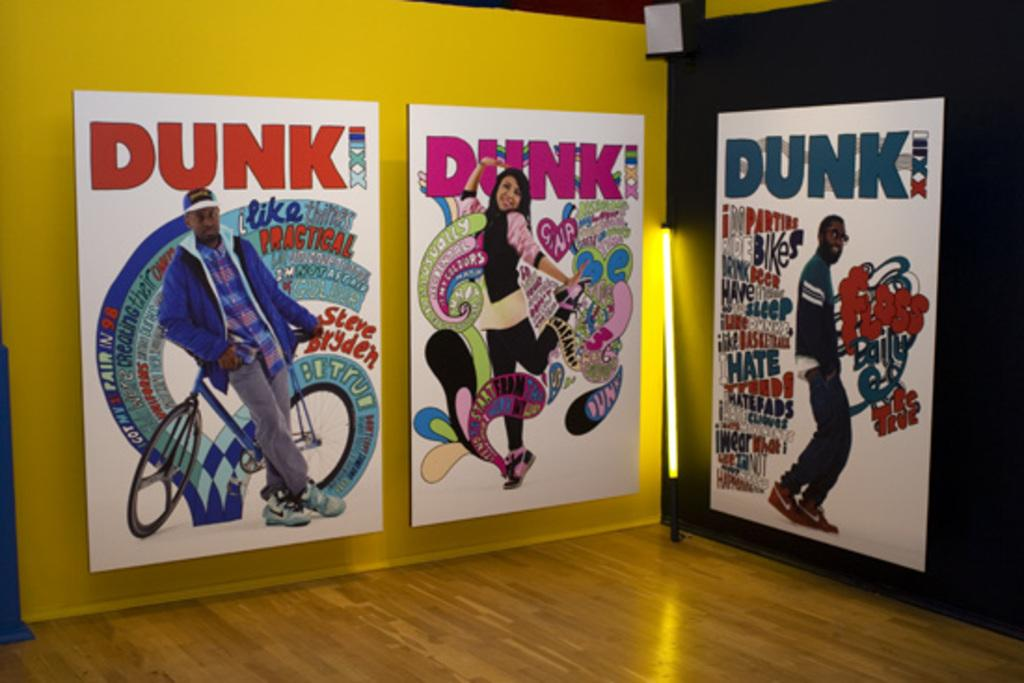Provide a one-sentence caption for the provided image. The displayed pop-art has the word DUNK at the top of each one. 